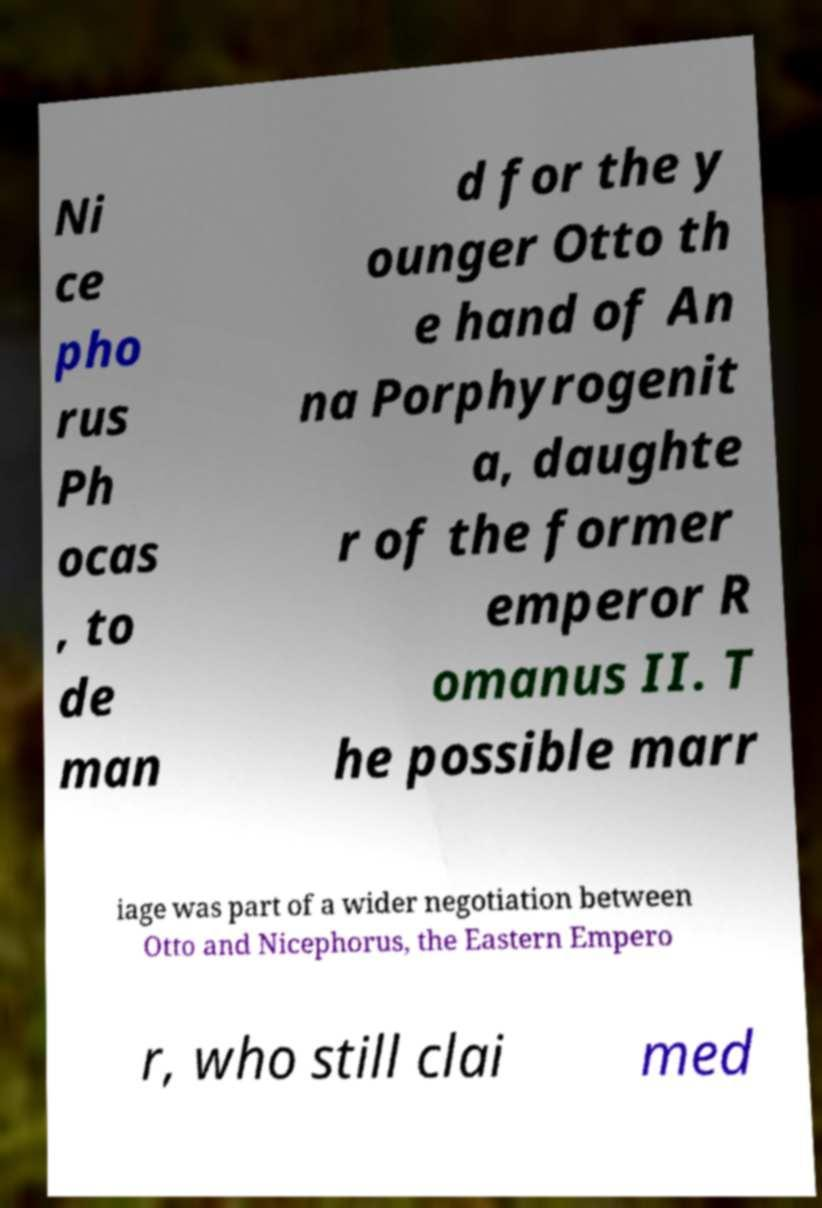I need the written content from this picture converted into text. Can you do that? Ni ce pho rus Ph ocas , to de man d for the y ounger Otto th e hand of An na Porphyrogenit a, daughte r of the former emperor R omanus II. T he possible marr iage was part of a wider negotiation between Otto and Nicephorus, the Eastern Empero r, who still clai med 